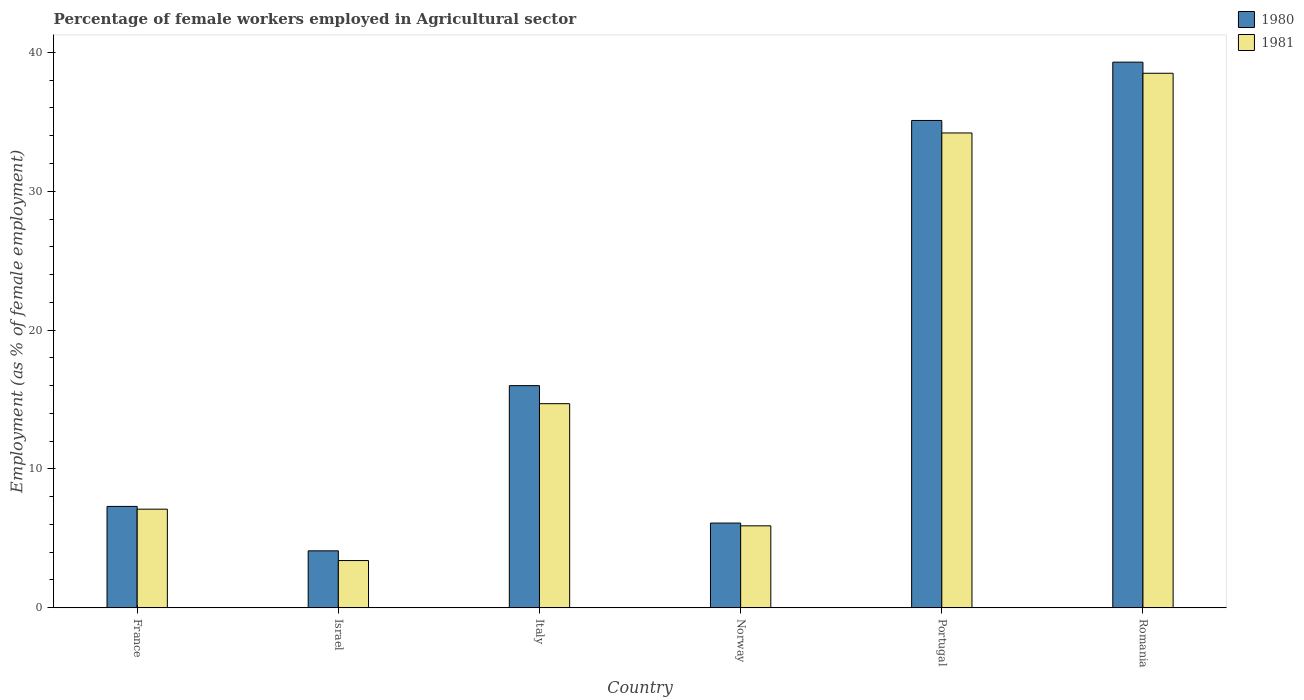What is the label of the 3rd group of bars from the left?
Give a very brief answer. Italy. What is the percentage of females employed in Agricultural sector in 1980 in Portugal?
Provide a succinct answer. 35.1. Across all countries, what is the maximum percentage of females employed in Agricultural sector in 1980?
Offer a very short reply. 39.3. Across all countries, what is the minimum percentage of females employed in Agricultural sector in 1981?
Keep it short and to the point. 3.4. In which country was the percentage of females employed in Agricultural sector in 1980 maximum?
Your answer should be compact. Romania. What is the total percentage of females employed in Agricultural sector in 1980 in the graph?
Ensure brevity in your answer.  107.9. What is the difference between the percentage of females employed in Agricultural sector in 1981 in Portugal and that in Romania?
Your answer should be very brief. -4.3. What is the difference between the percentage of females employed in Agricultural sector in 1980 in Italy and the percentage of females employed in Agricultural sector in 1981 in Israel?
Provide a succinct answer. 12.6. What is the average percentage of females employed in Agricultural sector in 1981 per country?
Ensure brevity in your answer.  17.3. What is the difference between the percentage of females employed in Agricultural sector of/in 1981 and percentage of females employed in Agricultural sector of/in 1980 in Romania?
Give a very brief answer. -0.8. What is the ratio of the percentage of females employed in Agricultural sector in 1980 in France to that in Norway?
Your answer should be very brief. 1.2. What is the difference between the highest and the second highest percentage of females employed in Agricultural sector in 1981?
Keep it short and to the point. -4.3. What is the difference between the highest and the lowest percentage of females employed in Agricultural sector in 1980?
Your response must be concise. 35.2. In how many countries, is the percentage of females employed in Agricultural sector in 1980 greater than the average percentage of females employed in Agricultural sector in 1980 taken over all countries?
Your response must be concise. 2. Is the sum of the percentage of females employed in Agricultural sector in 1981 in Israel and Norway greater than the maximum percentage of females employed in Agricultural sector in 1980 across all countries?
Provide a succinct answer. No. How many countries are there in the graph?
Offer a very short reply. 6. What is the difference between two consecutive major ticks on the Y-axis?
Give a very brief answer. 10. Does the graph contain any zero values?
Your answer should be very brief. No. Does the graph contain grids?
Your answer should be very brief. No. Where does the legend appear in the graph?
Make the answer very short. Top right. How are the legend labels stacked?
Provide a short and direct response. Vertical. What is the title of the graph?
Provide a succinct answer. Percentage of female workers employed in Agricultural sector. Does "1978" appear as one of the legend labels in the graph?
Keep it short and to the point. No. What is the label or title of the X-axis?
Your response must be concise. Country. What is the label or title of the Y-axis?
Your answer should be very brief. Employment (as % of female employment). What is the Employment (as % of female employment) in 1980 in France?
Your answer should be compact. 7.3. What is the Employment (as % of female employment) in 1981 in France?
Provide a short and direct response. 7.1. What is the Employment (as % of female employment) of 1980 in Israel?
Provide a short and direct response. 4.1. What is the Employment (as % of female employment) in 1981 in Israel?
Give a very brief answer. 3.4. What is the Employment (as % of female employment) in 1981 in Italy?
Make the answer very short. 14.7. What is the Employment (as % of female employment) in 1980 in Norway?
Provide a succinct answer. 6.1. What is the Employment (as % of female employment) of 1981 in Norway?
Your answer should be very brief. 5.9. What is the Employment (as % of female employment) in 1980 in Portugal?
Keep it short and to the point. 35.1. What is the Employment (as % of female employment) of 1981 in Portugal?
Ensure brevity in your answer.  34.2. What is the Employment (as % of female employment) in 1980 in Romania?
Offer a terse response. 39.3. What is the Employment (as % of female employment) of 1981 in Romania?
Your answer should be very brief. 38.5. Across all countries, what is the maximum Employment (as % of female employment) of 1980?
Provide a succinct answer. 39.3. Across all countries, what is the maximum Employment (as % of female employment) in 1981?
Your answer should be compact. 38.5. Across all countries, what is the minimum Employment (as % of female employment) in 1980?
Keep it short and to the point. 4.1. Across all countries, what is the minimum Employment (as % of female employment) of 1981?
Your answer should be very brief. 3.4. What is the total Employment (as % of female employment) in 1980 in the graph?
Give a very brief answer. 107.9. What is the total Employment (as % of female employment) of 1981 in the graph?
Ensure brevity in your answer.  103.8. What is the difference between the Employment (as % of female employment) in 1980 in France and that in Israel?
Ensure brevity in your answer.  3.2. What is the difference between the Employment (as % of female employment) of 1980 in France and that in Italy?
Ensure brevity in your answer.  -8.7. What is the difference between the Employment (as % of female employment) of 1981 in France and that in Italy?
Your answer should be compact. -7.6. What is the difference between the Employment (as % of female employment) of 1980 in France and that in Norway?
Provide a succinct answer. 1.2. What is the difference between the Employment (as % of female employment) of 1980 in France and that in Portugal?
Provide a short and direct response. -27.8. What is the difference between the Employment (as % of female employment) of 1981 in France and that in Portugal?
Provide a succinct answer. -27.1. What is the difference between the Employment (as % of female employment) in 1980 in France and that in Romania?
Your answer should be compact. -32. What is the difference between the Employment (as % of female employment) in 1981 in France and that in Romania?
Make the answer very short. -31.4. What is the difference between the Employment (as % of female employment) of 1980 in Israel and that in Italy?
Offer a very short reply. -11.9. What is the difference between the Employment (as % of female employment) of 1980 in Israel and that in Portugal?
Your response must be concise. -31. What is the difference between the Employment (as % of female employment) in 1981 in Israel and that in Portugal?
Your answer should be very brief. -30.8. What is the difference between the Employment (as % of female employment) of 1980 in Israel and that in Romania?
Your response must be concise. -35.2. What is the difference between the Employment (as % of female employment) of 1981 in Israel and that in Romania?
Ensure brevity in your answer.  -35.1. What is the difference between the Employment (as % of female employment) in 1980 in Italy and that in Norway?
Provide a succinct answer. 9.9. What is the difference between the Employment (as % of female employment) in 1980 in Italy and that in Portugal?
Offer a very short reply. -19.1. What is the difference between the Employment (as % of female employment) in 1981 in Italy and that in Portugal?
Offer a terse response. -19.5. What is the difference between the Employment (as % of female employment) of 1980 in Italy and that in Romania?
Provide a succinct answer. -23.3. What is the difference between the Employment (as % of female employment) of 1981 in Italy and that in Romania?
Ensure brevity in your answer.  -23.8. What is the difference between the Employment (as % of female employment) in 1981 in Norway and that in Portugal?
Your response must be concise. -28.3. What is the difference between the Employment (as % of female employment) in 1980 in Norway and that in Romania?
Provide a short and direct response. -33.2. What is the difference between the Employment (as % of female employment) of 1981 in Norway and that in Romania?
Keep it short and to the point. -32.6. What is the difference between the Employment (as % of female employment) of 1980 in Portugal and that in Romania?
Ensure brevity in your answer.  -4.2. What is the difference between the Employment (as % of female employment) of 1981 in Portugal and that in Romania?
Ensure brevity in your answer.  -4.3. What is the difference between the Employment (as % of female employment) in 1980 in France and the Employment (as % of female employment) in 1981 in Israel?
Offer a terse response. 3.9. What is the difference between the Employment (as % of female employment) of 1980 in France and the Employment (as % of female employment) of 1981 in Norway?
Your response must be concise. 1.4. What is the difference between the Employment (as % of female employment) in 1980 in France and the Employment (as % of female employment) in 1981 in Portugal?
Ensure brevity in your answer.  -26.9. What is the difference between the Employment (as % of female employment) of 1980 in France and the Employment (as % of female employment) of 1981 in Romania?
Keep it short and to the point. -31.2. What is the difference between the Employment (as % of female employment) of 1980 in Israel and the Employment (as % of female employment) of 1981 in Italy?
Offer a very short reply. -10.6. What is the difference between the Employment (as % of female employment) in 1980 in Israel and the Employment (as % of female employment) in 1981 in Norway?
Give a very brief answer. -1.8. What is the difference between the Employment (as % of female employment) in 1980 in Israel and the Employment (as % of female employment) in 1981 in Portugal?
Keep it short and to the point. -30.1. What is the difference between the Employment (as % of female employment) in 1980 in Israel and the Employment (as % of female employment) in 1981 in Romania?
Offer a very short reply. -34.4. What is the difference between the Employment (as % of female employment) in 1980 in Italy and the Employment (as % of female employment) in 1981 in Portugal?
Your response must be concise. -18.2. What is the difference between the Employment (as % of female employment) in 1980 in Italy and the Employment (as % of female employment) in 1981 in Romania?
Your answer should be very brief. -22.5. What is the difference between the Employment (as % of female employment) in 1980 in Norway and the Employment (as % of female employment) in 1981 in Portugal?
Give a very brief answer. -28.1. What is the difference between the Employment (as % of female employment) of 1980 in Norway and the Employment (as % of female employment) of 1981 in Romania?
Your response must be concise. -32.4. What is the average Employment (as % of female employment) in 1980 per country?
Give a very brief answer. 17.98. What is the average Employment (as % of female employment) of 1981 per country?
Offer a very short reply. 17.3. What is the difference between the Employment (as % of female employment) in 1980 and Employment (as % of female employment) in 1981 in Israel?
Keep it short and to the point. 0.7. What is the difference between the Employment (as % of female employment) in 1980 and Employment (as % of female employment) in 1981 in Norway?
Your response must be concise. 0.2. What is the difference between the Employment (as % of female employment) in 1980 and Employment (as % of female employment) in 1981 in Portugal?
Ensure brevity in your answer.  0.9. What is the difference between the Employment (as % of female employment) of 1980 and Employment (as % of female employment) of 1981 in Romania?
Offer a very short reply. 0.8. What is the ratio of the Employment (as % of female employment) in 1980 in France to that in Israel?
Your answer should be very brief. 1.78. What is the ratio of the Employment (as % of female employment) in 1981 in France to that in Israel?
Offer a terse response. 2.09. What is the ratio of the Employment (as % of female employment) of 1980 in France to that in Italy?
Your answer should be very brief. 0.46. What is the ratio of the Employment (as % of female employment) of 1981 in France to that in Italy?
Your answer should be compact. 0.48. What is the ratio of the Employment (as % of female employment) in 1980 in France to that in Norway?
Ensure brevity in your answer.  1.2. What is the ratio of the Employment (as % of female employment) in 1981 in France to that in Norway?
Offer a terse response. 1.2. What is the ratio of the Employment (as % of female employment) in 1980 in France to that in Portugal?
Offer a very short reply. 0.21. What is the ratio of the Employment (as % of female employment) in 1981 in France to that in Portugal?
Your answer should be very brief. 0.21. What is the ratio of the Employment (as % of female employment) of 1980 in France to that in Romania?
Provide a short and direct response. 0.19. What is the ratio of the Employment (as % of female employment) in 1981 in France to that in Romania?
Your answer should be compact. 0.18. What is the ratio of the Employment (as % of female employment) in 1980 in Israel to that in Italy?
Your response must be concise. 0.26. What is the ratio of the Employment (as % of female employment) in 1981 in Israel to that in Italy?
Provide a short and direct response. 0.23. What is the ratio of the Employment (as % of female employment) in 1980 in Israel to that in Norway?
Your answer should be very brief. 0.67. What is the ratio of the Employment (as % of female employment) of 1981 in Israel to that in Norway?
Offer a very short reply. 0.58. What is the ratio of the Employment (as % of female employment) in 1980 in Israel to that in Portugal?
Your response must be concise. 0.12. What is the ratio of the Employment (as % of female employment) of 1981 in Israel to that in Portugal?
Make the answer very short. 0.1. What is the ratio of the Employment (as % of female employment) of 1980 in Israel to that in Romania?
Make the answer very short. 0.1. What is the ratio of the Employment (as % of female employment) of 1981 in Israel to that in Romania?
Keep it short and to the point. 0.09. What is the ratio of the Employment (as % of female employment) in 1980 in Italy to that in Norway?
Provide a short and direct response. 2.62. What is the ratio of the Employment (as % of female employment) in 1981 in Italy to that in Norway?
Offer a very short reply. 2.49. What is the ratio of the Employment (as % of female employment) in 1980 in Italy to that in Portugal?
Offer a terse response. 0.46. What is the ratio of the Employment (as % of female employment) in 1981 in Italy to that in Portugal?
Give a very brief answer. 0.43. What is the ratio of the Employment (as % of female employment) of 1980 in Italy to that in Romania?
Your response must be concise. 0.41. What is the ratio of the Employment (as % of female employment) in 1981 in Italy to that in Romania?
Make the answer very short. 0.38. What is the ratio of the Employment (as % of female employment) of 1980 in Norway to that in Portugal?
Your answer should be very brief. 0.17. What is the ratio of the Employment (as % of female employment) in 1981 in Norway to that in Portugal?
Your response must be concise. 0.17. What is the ratio of the Employment (as % of female employment) in 1980 in Norway to that in Romania?
Make the answer very short. 0.16. What is the ratio of the Employment (as % of female employment) of 1981 in Norway to that in Romania?
Ensure brevity in your answer.  0.15. What is the ratio of the Employment (as % of female employment) in 1980 in Portugal to that in Romania?
Make the answer very short. 0.89. What is the ratio of the Employment (as % of female employment) of 1981 in Portugal to that in Romania?
Your response must be concise. 0.89. What is the difference between the highest and the lowest Employment (as % of female employment) in 1980?
Give a very brief answer. 35.2. What is the difference between the highest and the lowest Employment (as % of female employment) of 1981?
Provide a succinct answer. 35.1. 